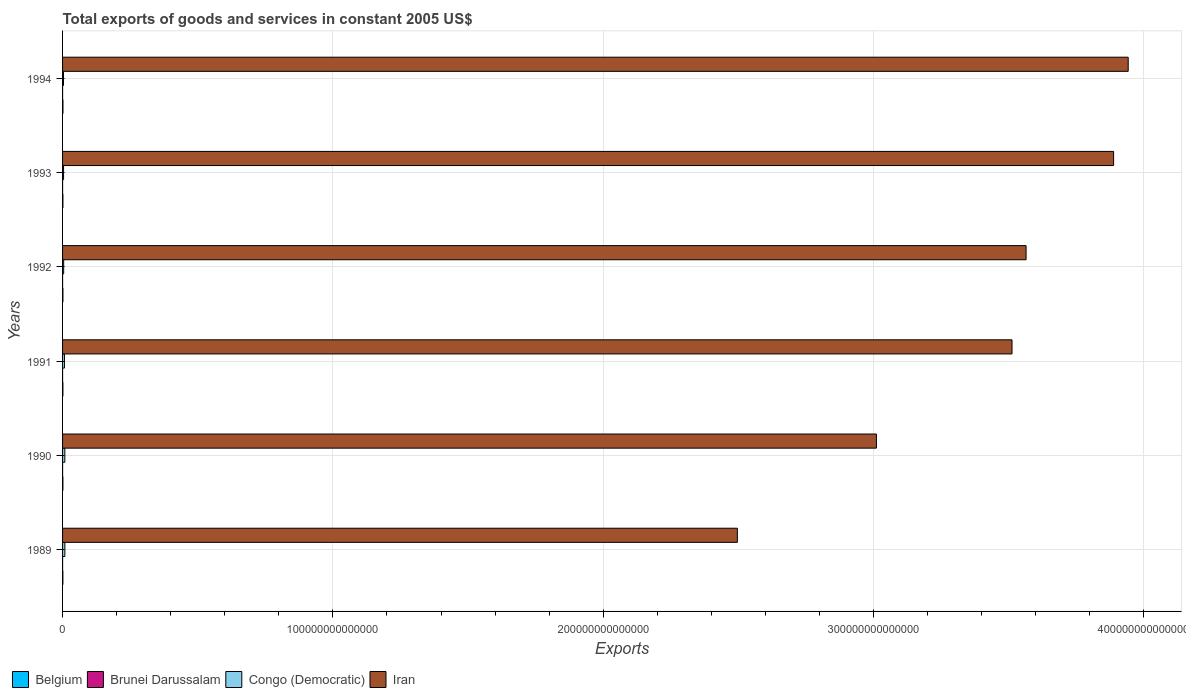Are the number of bars on each tick of the Y-axis equal?
Give a very brief answer. Yes. How many bars are there on the 5th tick from the bottom?
Make the answer very short. 4. What is the label of the 6th group of bars from the top?
Your answer should be compact. 1989. What is the total exports of goods and services in Congo (Democratic) in 1994?
Your answer should be very brief. 3.43e+11. Across all years, what is the maximum total exports of goods and services in Belgium?
Your answer should be very brief. 1.41e+11. Across all years, what is the minimum total exports of goods and services in Belgium?
Provide a succinct answer. 1.17e+11. In which year was the total exports of goods and services in Belgium maximum?
Offer a terse response. 1994. In which year was the total exports of goods and services in Brunei Darussalam minimum?
Give a very brief answer. 1989. What is the total total exports of goods and services in Congo (Democratic) in the graph?
Keep it short and to the point. 3.52e+12. What is the difference between the total exports of goods and services in Congo (Democratic) in 1989 and that in 1994?
Provide a succinct answer. 5.09e+11. What is the difference between the total exports of goods and services in Belgium in 1990 and the total exports of goods and services in Brunei Darussalam in 1993?
Offer a terse response. 1.17e+11. What is the average total exports of goods and services in Iran per year?
Provide a succinct answer. 3.40e+14. In the year 1989, what is the difference between the total exports of goods and services in Congo (Democratic) and total exports of goods and services in Iran?
Offer a very short reply. -2.49e+14. In how many years, is the total exports of goods and services in Iran greater than 140000000000000 US$?
Provide a short and direct response. 6. What is the ratio of the total exports of goods and services in Belgium in 1992 to that in 1993?
Ensure brevity in your answer.  1. Is the total exports of goods and services in Iran in 1992 less than that in 1994?
Offer a terse response. Yes. Is the difference between the total exports of goods and services in Congo (Democratic) in 1991 and 1992 greater than the difference between the total exports of goods and services in Iran in 1991 and 1992?
Offer a very short reply. Yes. What is the difference between the highest and the second highest total exports of goods and services in Belgium?
Offer a very short reply. 1.03e+1. What is the difference between the highest and the lowest total exports of goods and services in Brunei Darussalam?
Offer a very short reply. 8.16e+08. In how many years, is the total exports of goods and services in Iran greater than the average total exports of goods and services in Iran taken over all years?
Your answer should be compact. 4. Is it the case that in every year, the sum of the total exports of goods and services in Iran and total exports of goods and services in Belgium is greater than the sum of total exports of goods and services in Congo (Democratic) and total exports of goods and services in Brunei Darussalam?
Your answer should be compact. No. What does the 1st bar from the top in 1992 represents?
Make the answer very short. Iran. What does the 2nd bar from the bottom in 1991 represents?
Provide a succinct answer. Brunei Darussalam. How many bars are there?
Offer a terse response. 24. What is the difference between two consecutive major ticks on the X-axis?
Ensure brevity in your answer.  1.00e+14. Does the graph contain grids?
Your answer should be very brief. Yes. Where does the legend appear in the graph?
Make the answer very short. Bottom left. How many legend labels are there?
Make the answer very short. 4. What is the title of the graph?
Offer a very short reply. Total exports of goods and services in constant 2005 US$. Does "Lesotho" appear as one of the legend labels in the graph?
Keep it short and to the point. No. What is the label or title of the X-axis?
Make the answer very short. Exports. What is the Exports of Belgium in 1989?
Your answer should be very brief. 1.17e+11. What is the Exports in Brunei Darussalam in 1989?
Offer a terse response. 4.85e+09. What is the Exports of Congo (Democratic) in 1989?
Make the answer very short. 8.52e+11. What is the Exports of Iran in 1989?
Keep it short and to the point. 2.50e+14. What is the Exports of Belgium in 1990?
Your answer should be very brief. 1.22e+11. What is the Exports of Brunei Darussalam in 1990?
Make the answer very short. 4.92e+09. What is the Exports of Congo (Democratic) in 1990?
Give a very brief answer. 8.44e+11. What is the Exports of Iran in 1990?
Give a very brief answer. 3.01e+14. What is the Exports in Belgium in 1991?
Your response must be concise. 1.26e+11. What is the Exports of Brunei Darussalam in 1991?
Your answer should be compact. 5.35e+09. What is the Exports in Congo (Democratic) in 1991?
Offer a terse response. 7.00e+11. What is the Exports in Iran in 1991?
Your answer should be very brief. 3.51e+14. What is the Exports in Belgium in 1992?
Ensure brevity in your answer.  1.31e+11. What is the Exports in Brunei Darussalam in 1992?
Make the answer very short. 5.67e+09. What is the Exports of Congo (Democratic) in 1992?
Provide a short and direct response. 4.08e+11. What is the Exports of Iran in 1992?
Make the answer very short. 3.56e+14. What is the Exports of Belgium in 1993?
Your answer should be compact. 1.30e+11. What is the Exports in Brunei Darussalam in 1993?
Provide a succinct answer. 5.51e+09. What is the Exports in Congo (Democratic) in 1993?
Give a very brief answer. 3.71e+11. What is the Exports in Iran in 1993?
Offer a terse response. 3.89e+14. What is the Exports in Belgium in 1994?
Your answer should be compact. 1.41e+11. What is the Exports of Brunei Darussalam in 1994?
Keep it short and to the point. 5.67e+09. What is the Exports in Congo (Democratic) in 1994?
Your response must be concise. 3.43e+11. What is the Exports of Iran in 1994?
Make the answer very short. 3.94e+14. Across all years, what is the maximum Exports of Belgium?
Your answer should be very brief. 1.41e+11. Across all years, what is the maximum Exports of Brunei Darussalam?
Your response must be concise. 5.67e+09. Across all years, what is the maximum Exports in Congo (Democratic)?
Provide a short and direct response. 8.52e+11. Across all years, what is the maximum Exports of Iran?
Your answer should be compact. 3.94e+14. Across all years, what is the minimum Exports of Belgium?
Provide a succinct answer. 1.17e+11. Across all years, what is the minimum Exports in Brunei Darussalam?
Provide a short and direct response. 4.85e+09. Across all years, what is the minimum Exports of Congo (Democratic)?
Offer a terse response. 3.43e+11. Across all years, what is the minimum Exports in Iran?
Provide a succinct answer. 2.50e+14. What is the total Exports of Belgium in the graph?
Provide a short and direct response. 7.68e+11. What is the total Exports in Brunei Darussalam in the graph?
Keep it short and to the point. 3.20e+1. What is the total Exports of Congo (Democratic) in the graph?
Your answer should be compact. 3.52e+12. What is the total Exports in Iran in the graph?
Your answer should be compact. 2.04e+15. What is the difference between the Exports in Belgium in 1989 and that in 1990?
Provide a succinct answer. -5.35e+09. What is the difference between the Exports in Brunei Darussalam in 1989 and that in 1990?
Provide a short and direct response. -6.20e+07. What is the difference between the Exports in Congo (Democratic) in 1989 and that in 1990?
Give a very brief answer. 8.36e+09. What is the difference between the Exports of Iran in 1989 and that in 1990?
Offer a terse response. -5.14e+13. What is the difference between the Exports in Belgium in 1989 and that in 1991?
Offer a terse response. -9.09e+09. What is the difference between the Exports of Brunei Darussalam in 1989 and that in 1991?
Make the answer very short. -4.93e+08. What is the difference between the Exports of Congo (Democratic) in 1989 and that in 1991?
Provide a short and direct response. 1.53e+11. What is the difference between the Exports in Iran in 1989 and that in 1991?
Your answer should be very brief. -1.02e+14. What is the difference between the Exports of Belgium in 1989 and that in 1992?
Provide a short and direct response. -1.37e+1. What is the difference between the Exports in Brunei Darussalam in 1989 and that in 1992?
Your answer should be very brief. -8.16e+08. What is the difference between the Exports in Congo (Democratic) in 1989 and that in 1992?
Give a very brief answer. 4.45e+11. What is the difference between the Exports in Iran in 1989 and that in 1992?
Offer a terse response. -1.07e+14. What is the difference between the Exports in Belgium in 1989 and that in 1993?
Make the answer very short. -1.31e+1. What is the difference between the Exports of Brunei Darussalam in 1989 and that in 1993?
Ensure brevity in your answer.  -6.58e+08. What is the difference between the Exports in Congo (Democratic) in 1989 and that in 1993?
Make the answer very short. 4.81e+11. What is the difference between the Exports in Iran in 1989 and that in 1993?
Provide a short and direct response. -1.39e+14. What is the difference between the Exports in Belgium in 1989 and that in 1994?
Provide a short and direct response. -2.40e+1. What is the difference between the Exports of Brunei Darussalam in 1989 and that in 1994?
Ensure brevity in your answer.  -8.15e+08. What is the difference between the Exports of Congo (Democratic) in 1989 and that in 1994?
Offer a very short reply. 5.09e+11. What is the difference between the Exports of Iran in 1989 and that in 1994?
Your response must be concise. -1.45e+14. What is the difference between the Exports of Belgium in 1990 and that in 1991?
Give a very brief answer. -3.74e+09. What is the difference between the Exports of Brunei Darussalam in 1990 and that in 1991?
Offer a very short reply. -4.31e+08. What is the difference between the Exports of Congo (Democratic) in 1990 and that in 1991?
Offer a terse response. 1.44e+11. What is the difference between the Exports of Iran in 1990 and that in 1991?
Ensure brevity in your answer.  -5.02e+13. What is the difference between the Exports of Belgium in 1990 and that in 1992?
Keep it short and to the point. -8.37e+09. What is the difference between the Exports of Brunei Darussalam in 1990 and that in 1992?
Provide a short and direct response. -7.54e+08. What is the difference between the Exports of Congo (Democratic) in 1990 and that in 1992?
Your answer should be compact. 4.37e+11. What is the difference between the Exports in Iran in 1990 and that in 1992?
Your answer should be compact. -5.54e+13. What is the difference between the Exports in Belgium in 1990 and that in 1993?
Offer a terse response. -7.79e+09. What is the difference between the Exports in Brunei Darussalam in 1990 and that in 1993?
Offer a terse response. -5.96e+08. What is the difference between the Exports of Congo (Democratic) in 1990 and that in 1993?
Make the answer very short. 4.73e+11. What is the difference between the Exports of Iran in 1990 and that in 1993?
Offer a very short reply. -8.77e+13. What is the difference between the Exports in Belgium in 1990 and that in 1994?
Your answer should be very brief. -1.86e+1. What is the difference between the Exports of Brunei Darussalam in 1990 and that in 1994?
Offer a terse response. -7.53e+08. What is the difference between the Exports in Congo (Democratic) in 1990 and that in 1994?
Your answer should be compact. 5.01e+11. What is the difference between the Exports in Iran in 1990 and that in 1994?
Keep it short and to the point. -9.31e+13. What is the difference between the Exports of Belgium in 1991 and that in 1992?
Your answer should be compact. -4.63e+09. What is the difference between the Exports in Brunei Darussalam in 1991 and that in 1992?
Provide a succinct answer. -3.23e+08. What is the difference between the Exports in Congo (Democratic) in 1991 and that in 1992?
Offer a very short reply. 2.92e+11. What is the difference between the Exports in Iran in 1991 and that in 1992?
Your answer should be compact. -5.20e+12. What is the difference between the Exports in Belgium in 1991 and that in 1993?
Provide a succinct answer. -4.05e+09. What is the difference between the Exports of Brunei Darussalam in 1991 and that in 1993?
Ensure brevity in your answer.  -1.65e+08. What is the difference between the Exports of Congo (Democratic) in 1991 and that in 1993?
Ensure brevity in your answer.  3.28e+11. What is the difference between the Exports of Iran in 1991 and that in 1993?
Keep it short and to the point. -3.76e+13. What is the difference between the Exports of Belgium in 1991 and that in 1994?
Make the answer very short. -1.49e+1. What is the difference between the Exports of Brunei Darussalam in 1991 and that in 1994?
Give a very brief answer. -3.22e+08. What is the difference between the Exports in Congo (Democratic) in 1991 and that in 1994?
Provide a short and direct response. 3.56e+11. What is the difference between the Exports in Iran in 1991 and that in 1994?
Ensure brevity in your answer.  -4.30e+13. What is the difference between the Exports of Belgium in 1992 and that in 1993?
Make the answer very short. 5.78e+08. What is the difference between the Exports of Brunei Darussalam in 1992 and that in 1993?
Offer a very short reply. 1.58e+08. What is the difference between the Exports of Congo (Democratic) in 1992 and that in 1993?
Provide a succinct answer. 3.62e+1. What is the difference between the Exports of Iran in 1992 and that in 1993?
Your answer should be very brief. -3.24e+13. What is the difference between the Exports in Belgium in 1992 and that in 1994?
Your response must be concise. -1.03e+1. What is the difference between the Exports in Congo (Democratic) in 1992 and that in 1994?
Your response must be concise. 6.41e+1. What is the difference between the Exports of Iran in 1992 and that in 1994?
Your response must be concise. -3.78e+13. What is the difference between the Exports of Belgium in 1993 and that in 1994?
Your answer should be compact. -1.08e+1. What is the difference between the Exports in Brunei Darussalam in 1993 and that in 1994?
Give a very brief answer. -1.57e+08. What is the difference between the Exports of Congo (Democratic) in 1993 and that in 1994?
Give a very brief answer. 2.79e+1. What is the difference between the Exports in Iran in 1993 and that in 1994?
Your answer should be very brief. -5.40e+12. What is the difference between the Exports in Belgium in 1989 and the Exports in Brunei Darussalam in 1990?
Ensure brevity in your answer.  1.12e+11. What is the difference between the Exports in Belgium in 1989 and the Exports in Congo (Democratic) in 1990?
Offer a terse response. -7.27e+11. What is the difference between the Exports in Belgium in 1989 and the Exports in Iran in 1990?
Make the answer very short. -3.01e+14. What is the difference between the Exports of Brunei Darussalam in 1989 and the Exports of Congo (Democratic) in 1990?
Make the answer very short. -8.39e+11. What is the difference between the Exports of Brunei Darussalam in 1989 and the Exports of Iran in 1990?
Your response must be concise. -3.01e+14. What is the difference between the Exports in Congo (Democratic) in 1989 and the Exports in Iran in 1990?
Provide a succinct answer. -3.00e+14. What is the difference between the Exports of Belgium in 1989 and the Exports of Brunei Darussalam in 1991?
Give a very brief answer. 1.12e+11. What is the difference between the Exports of Belgium in 1989 and the Exports of Congo (Democratic) in 1991?
Give a very brief answer. -5.83e+11. What is the difference between the Exports of Belgium in 1989 and the Exports of Iran in 1991?
Your response must be concise. -3.51e+14. What is the difference between the Exports in Brunei Darussalam in 1989 and the Exports in Congo (Democratic) in 1991?
Ensure brevity in your answer.  -6.95e+11. What is the difference between the Exports in Brunei Darussalam in 1989 and the Exports in Iran in 1991?
Ensure brevity in your answer.  -3.51e+14. What is the difference between the Exports in Congo (Democratic) in 1989 and the Exports in Iran in 1991?
Offer a terse response. -3.50e+14. What is the difference between the Exports in Belgium in 1989 and the Exports in Brunei Darussalam in 1992?
Give a very brief answer. 1.11e+11. What is the difference between the Exports in Belgium in 1989 and the Exports in Congo (Democratic) in 1992?
Your answer should be compact. -2.90e+11. What is the difference between the Exports in Belgium in 1989 and the Exports in Iran in 1992?
Your response must be concise. -3.56e+14. What is the difference between the Exports in Brunei Darussalam in 1989 and the Exports in Congo (Democratic) in 1992?
Your answer should be compact. -4.03e+11. What is the difference between the Exports of Brunei Darussalam in 1989 and the Exports of Iran in 1992?
Make the answer very short. -3.56e+14. What is the difference between the Exports of Congo (Democratic) in 1989 and the Exports of Iran in 1992?
Provide a succinct answer. -3.56e+14. What is the difference between the Exports in Belgium in 1989 and the Exports in Brunei Darussalam in 1993?
Your answer should be compact. 1.12e+11. What is the difference between the Exports of Belgium in 1989 and the Exports of Congo (Democratic) in 1993?
Give a very brief answer. -2.54e+11. What is the difference between the Exports in Belgium in 1989 and the Exports in Iran in 1993?
Give a very brief answer. -3.89e+14. What is the difference between the Exports in Brunei Darussalam in 1989 and the Exports in Congo (Democratic) in 1993?
Your response must be concise. -3.66e+11. What is the difference between the Exports in Brunei Darussalam in 1989 and the Exports in Iran in 1993?
Offer a very short reply. -3.89e+14. What is the difference between the Exports of Congo (Democratic) in 1989 and the Exports of Iran in 1993?
Your response must be concise. -3.88e+14. What is the difference between the Exports in Belgium in 1989 and the Exports in Brunei Darussalam in 1994?
Your answer should be compact. 1.11e+11. What is the difference between the Exports of Belgium in 1989 and the Exports of Congo (Democratic) in 1994?
Make the answer very short. -2.26e+11. What is the difference between the Exports of Belgium in 1989 and the Exports of Iran in 1994?
Your answer should be very brief. -3.94e+14. What is the difference between the Exports in Brunei Darussalam in 1989 and the Exports in Congo (Democratic) in 1994?
Offer a terse response. -3.39e+11. What is the difference between the Exports of Brunei Darussalam in 1989 and the Exports of Iran in 1994?
Your answer should be compact. -3.94e+14. What is the difference between the Exports in Congo (Democratic) in 1989 and the Exports in Iran in 1994?
Your answer should be compact. -3.93e+14. What is the difference between the Exports in Belgium in 1990 and the Exports in Brunei Darussalam in 1991?
Keep it short and to the point. 1.17e+11. What is the difference between the Exports of Belgium in 1990 and the Exports of Congo (Democratic) in 1991?
Your answer should be compact. -5.77e+11. What is the difference between the Exports in Belgium in 1990 and the Exports in Iran in 1991?
Offer a very short reply. -3.51e+14. What is the difference between the Exports in Brunei Darussalam in 1990 and the Exports in Congo (Democratic) in 1991?
Offer a very short reply. -6.95e+11. What is the difference between the Exports in Brunei Darussalam in 1990 and the Exports in Iran in 1991?
Keep it short and to the point. -3.51e+14. What is the difference between the Exports of Congo (Democratic) in 1990 and the Exports of Iran in 1991?
Keep it short and to the point. -3.50e+14. What is the difference between the Exports of Belgium in 1990 and the Exports of Brunei Darussalam in 1992?
Make the answer very short. 1.17e+11. What is the difference between the Exports of Belgium in 1990 and the Exports of Congo (Democratic) in 1992?
Offer a terse response. -2.85e+11. What is the difference between the Exports in Belgium in 1990 and the Exports in Iran in 1992?
Your response must be concise. -3.56e+14. What is the difference between the Exports of Brunei Darussalam in 1990 and the Exports of Congo (Democratic) in 1992?
Provide a short and direct response. -4.03e+11. What is the difference between the Exports in Brunei Darussalam in 1990 and the Exports in Iran in 1992?
Give a very brief answer. -3.56e+14. What is the difference between the Exports of Congo (Democratic) in 1990 and the Exports of Iran in 1992?
Ensure brevity in your answer.  -3.56e+14. What is the difference between the Exports of Belgium in 1990 and the Exports of Brunei Darussalam in 1993?
Your response must be concise. 1.17e+11. What is the difference between the Exports in Belgium in 1990 and the Exports in Congo (Democratic) in 1993?
Ensure brevity in your answer.  -2.49e+11. What is the difference between the Exports of Belgium in 1990 and the Exports of Iran in 1993?
Your response must be concise. -3.89e+14. What is the difference between the Exports of Brunei Darussalam in 1990 and the Exports of Congo (Democratic) in 1993?
Your response must be concise. -3.66e+11. What is the difference between the Exports of Brunei Darussalam in 1990 and the Exports of Iran in 1993?
Provide a short and direct response. -3.89e+14. What is the difference between the Exports in Congo (Democratic) in 1990 and the Exports in Iran in 1993?
Your answer should be compact. -3.88e+14. What is the difference between the Exports in Belgium in 1990 and the Exports in Brunei Darussalam in 1994?
Your answer should be compact. 1.17e+11. What is the difference between the Exports of Belgium in 1990 and the Exports of Congo (Democratic) in 1994?
Provide a succinct answer. -2.21e+11. What is the difference between the Exports in Belgium in 1990 and the Exports in Iran in 1994?
Give a very brief answer. -3.94e+14. What is the difference between the Exports in Brunei Darussalam in 1990 and the Exports in Congo (Democratic) in 1994?
Your answer should be compact. -3.39e+11. What is the difference between the Exports of Brunei Darussalam in 1990 and the Exports of Iran in 1994?
Provide a short and direct response. -3.94e+14. What is the difference between the Exports in Congo (Democratic) in 1990 and the Exports in Iran in 1994?
Offer a very short reply. -3.93e+14. What is the difference between the Exports of Belgium in 1991 and the Exports of Brunei Darussalam in 1992?
Give a very brief answer. 1.20e+11. What is the difference between the Exports in Belgium in 1991 and the Exports in Congo (Democratic) in 1992?
Your answer should be very brief. -2.81e+11. What is the difference between the Exports of Belgium in 1991 and the Exports of Iran in 1992?
Offer a terse response. -3.56e+14. What is the difference between the Exports of Brunei Darussalam in 1991 and the Exports of Congo (Democratic) in 1992?
Make the answer very short. -4.02e+11. What is the difference between the Exports in Brunei Darussalam in 1991 and the Exports in Iran in 1992?
Offer a terse response. -3.56e+14. What is the difference between the Exports in Congo (Democratic) in 1991 and the Exports in Iran in 1992?
Your response must be concise. -3.56e+14. What is the difference between the Exports of Belgium in 1991 and the Exports of Brunei Darussalam in 1993?
Provide a succinct answer. 1.21e+11. What is the difference between the Exports in Belgium in 1991 and the Exports in Congo (Democratic) in 1993?
Keep it short and to the point. -2.45e+11. What is the difference between the Exports of Belgium in 1991 and the Exports of Iran in 1993?
Give a very brief answer. -3.89e+14. What is the difference between the Exports of Brunei Darussalam in 1991 and the Exports of Congo (Democratic) in 1993?
Provide a short and direct response. -3.66e+11. What is the difference between the Exports in Brunei Darussalam in 1991 and the Exports in Iran in 1993?
Ensure brevity in your answer.  -3.89e+14. What is the difference between the Exports of Congo (Democratic) in 1991 and the Exports of Iran in 1993?
Your answer should be very brief. -3.88e+14. What is the difference between the Exports of Belgium in 1991 and the Exports of Brunei Darussalam in 1994?
Your response must be concise. 1.20e+11. What is the difference between the Exports of Belgium in 1991 and the Exports of Congo (Democratic) in 1994?
Provide a short and direct response. -2.17e+11. What is the difference between the Exports of Belgium in 1991 and the Exports of Iran in 1994?
Keep it short and to the point. -3.94e+14. What is the difference between the Exports of Brunei Darussalam in 1991 and the Exports of Congo (Democratic) in 1994?
Ensure brevity in your answer.  -3.38e+11. What is the difference between the Exports of Brunei Darussalam in 1991 and the Exports of Iran in 1994?
Your answer should be compact. -3.94e+14. What is the difference between the Exports of Congo (Democratic) in 1991 and the Exports of Iran in 1994?
Make the answer very short. -3.93e+14. What is the difference between the Exports of Belgium in 1992 and the Exports of Brunei Darussalam in 1993?
Offer a very short reply. 1.25e+11. What is the difference between the Exports of Belgium in 1992 and the Exports of Congo (Democratic) in 1993?
Give a very brief answer. -2.41e+11. What is the difference between the Exports in Belgium in 1992 and the Exports in Iran in 1993?
Make the answer very short. -3.89e+14. What is the difference between the Exports in Brunei Darussalam in 1992 and the Exports in Congo (Democratic) in 1993?
Your answer should be very brief. -3.66e+11. What is the difference between the Exports of Brunei Darussalam in 1992 and the Exports of Iran in 1993?
Your answer should be very brief. -3.89e+14. What is the difference between the Exports in Congo (Democratic) in 1992 and the Exports in Iran in 1993?
Offer a very short reply. -3.88e+14. What is the difference between the Exports of Belgium in 1992 and the Exports of Brunei Darussalam in 1994?
Provide a succinct answer. 1.25e+11. What is the difference between the Exports in Belgium in 1992 and the Exports in Congo (Democratic) in 1994?
Offer a terse response. -2.13e+11. What is the difference between the Exports in Belgium in 1992 and the Exports in Iran in 1994?
Your answer should be compact. -3.94e+14. What is the difference between the Exports in Brunei Darussalam in 1992 and the Exports in Congo (Democratic) in 1994?
Provide a succinct answer. -3.38e+11. What is the difference between the Exports in Brunei Darussalam in 1992 and the Exports in Iran in 1994?
Ensure brevity in your answer.  -3.94e+14. What is the difference between the Exports of Congo (Democratic) in 1992 and the Exports of Iran in 1994?
Your answer should be very brief. -3.94e+14. What is the difference between the Exports of Belgium in 1993 and the Exports of Brunei Darussalam in 1994?
Make the answer very short. 1.25e+11. What is the difference between the Exports in Belgium in 1993 and the Exports in Congo (Democratic) in 1994?
Offer a very short reply. -2.13e+11. What is the difference between the Exports of Belgium in 1993 and the Exports of Iran in 1994?
Ensure brevity in your answer.  -3.94e+14. What is the difference between the Exports in Brunei Darussalam in 1993 and the Exports in Congo (Democratic) in 1994?
Make the answer very short. -3.38e+11. What is the difference between the Exports of Brunei Darussalam in 1993 and the Exports of Iran in 1994?
Your response must be concise. -3.94e+14. What is the difference between the Exports in Congo (Democratic) in 1993 and the Exports in Iran in 1994?
Ensure brevity in your answer.  -3.94e+14. What is the average Exports in Belgium per year?
Make the answer very short. 1.28e+11. What is the average Exports of Brunei Darussalam per year?
Offer a terse response. 5.33e+09. What is the average Exports in Congo (Democratic) per year?
Keep it short and to the point. 5.86e+11. What is the average Exports of Iran per year?
Provide a succinct answer. 3.40e+14. In the year 1989, what is the difference between the Exports of Belgium and Exports of Brunei Darussalam?
Your response must be concise. 1.12e+11. In the year 1989, what is the difference between the Exports of Belgium and Exports of Congo (Democratic)?
Your response must be concise. -7.35e+11. In the year 1989, what is the difference between the Exports in Belgium and Exports in Iran?
Your answer should be compact. -2.49e+14. In the year 1989, what is the difference between the Exports in Brunei Darussalam and Exports in Congo (Democratic)?
Ensure brevity in your answer.  -8.48e+11. In the year 1989, what is the difference between the Exports in Brunei Darussalam and Exports in Iran?
Keep it short and to the point. -2.50e+14. In the year 1989, what is the difference between the Exports in Congo (Democratic) and Exports in Iran?
Provide a succinct answer. -2.49e+14. In the year 1990, what is the difference between the Exports in Belgium and Exports in Brunei Darussalam?
Offer a very short reply. 1.17e+11. In the year 1990, what is the difference between the Exports in Belgium and Exports in Congo (Democratic)?
Provide a short and direct response. -7.22e+11. In the year 1990, what is the difference between the Exports in Belgium and Exports in Iran?
Offer a very short reply. -3.01e+14. In the year 1990, what is the difference between the Exports of Brunei Darussalam and Exports of Congo (Democratic)?
Your response must be concise. -8.39e+11. In the year 1990, what is the difference between the Exports in Brunei Darussalam and Exports in Iran?
Make the answer very short. -3.01e+14. In the year 1990, what is the difference between the Exports in Congo (Democratic) and Exports in Iran?
Offer a very short reply. -3.00e+14. In the year 1991, what is the difference between the Exports of Belgium and Exports of Brunei Darussalam?
Your answer should be compact. 1.21e+11. In the year 1991, what is the difference between the Exports of Belgium and Exports of Congo (Democratic)?
Make the answer very short. -5.73e+11. In the year 1991, what is the difference between the Exports in Belgium and Exports in Iran?
Provide a succinct answer. -3.51e+14. In the year 1991, what is the difference between the Exports of Brunei Darussalam and Exports of Congo (Democratic)?
Offer a very short reply. -6.94e+11. In the year 1991, what is the difference between the Exports in Brunei Darussalam and Exports in Iran?
Provide a succinct answer. -3.51e+14. In the year 1991, what is the difference between the Exports of Congo (Democratic) and Exports of Iran?
Keep it short and to the point. -3.51e+14. In the year 1992, what is the difference between the Exports of Belgium and Exports of Brunei Darussalam?
Offer a terse response. 1.25e+11. In the year 1992, what is the difference between the Exports in Belgium and Exports in Congo (Democratic)?
Your answer should be very brief. -2.77e+11. In the year 1992, what is the difference between the Exports of Belgium and Exports of Iran?
Provide a succinct answer. -3.56e+14. In the year 1992, what is the difference between the Exports of Brunei Darussalam and Exports of Congo (Democratic)?
Give a very brief answer. -4.02e+11. In the year 1992, what is the difference between the Exports in Brunei Darussalam and Exports in Iran?
Offer a very short reply. -3.56e+14. In the year 1992, what is the difference between the Exports in Congo (Democratic) and Exports in Iran?
Offer a terse response. -3.56e+14. In the year 1993, what is the difference between the Exports in Belgium and Exports in Brunei Darussalam?
Offer a very short reply. 1.25e+11. In the year 1993, what is the difference between the Exports in Belgium and Exports in Congo (Democratic)?
Your answer should be compact. -2.41e+11. In the year 1993, what is the difference between the Exports in Belgium and Exports in Iran?
Your response must be concise. -3.89e+14. In the year 1993, what is the difference between the Exports of Brunei Darussalam and Exports of Congo (Democratic)?
Give a very brief answer. -3.66e+11. In the year 1993, what is the difference between the Exports in Brunei Darussalam and Exports in Iran?
Offer a terse response. -3.89e+14. In the year 1993, what is the difference between the Exports of Congo (Democratic) and Exports of Iran?
Make the answer very short. -3.88e+14. In the year 1994, what is the difference between the Exports in Belgium and Exports in Brunei Darussalam?
Offer a very short reply. 1.35e+11. In the year 1994, what is the difference between the Exports in Belgium and Exports in Congo (Democratic)?
Provide a short and direct response. -2.02e+11. In the year 1994, what is the difference between the Exports in Belgium and Exports in Iran?
Make the answer very short. -3.94e+14. In the year 1994, what is the difference between the Exports of Brunei Darussalam and Exports of Congo (Democratic)?
Your response must be concise. -3.38e+11. In the year 1994, what is the difference between the Exports in Brunei Darussalam and Exports in Iran?
Offer a terse response. -3.94e+14. In the year 1994, what is the difference between the Exports of Congo (Democratic) and Exports of Iran?
Ensure brevity in your answer.  -3.94e+14. What is the ratio of the Exports of Belgium in 1989 to that in 1990?
Your response must be concise. 0.96. What is the ratio of the Exports in Brunei Darussalam in 1989 to that in 1990?
Your response must be concise. 0.99. What is the ratio of the Exports in Congo (Democratic) in 1989 to that in 1990?
Provide a succinct answer. 1.01. What is the ratio of the Exports in Iran in 1989 to that in 1990?
Your response must be concise. 0.83. What is the ratio of the Exports of Belgium in 1989 to that in 1991?
Your answer should be compact. 0.93. What is the ratio of the Exports of Brunei Darussalam in 1989 to that in 1991?
Your response must be concise. 0.91. What is the ratio of the Exports in Congo (Democratic) in 1989 to that in 1991?
Make the answer very short. 1.22. What is the ratio of the Exports of Iran in 1989 to that in 1991?
Offer a very short reply. 0.71. What is the ratio of the Exports of Belgium in 1989 to that in 1992?
Your answer should be compact. 0.9. What is the ratio of the Exports in Brunei Darussalam in 1989 to that in 1992?
Provide a short and direct response. 0.86. What is the ratio of the Exports of Congo (Democratic) in 1989 to that in 1992?
Keep it short and to the point. 2.09. What is the ratio of the Exports of Iran in 1989 to that in 1992?
Offer a terse response. 0.7. What is the ratio of the Exports in Belgium in 1989 to that in 1993?
Ensure brevity in your answer.  0.9. What is the ratio of the Exports of Brunei Darussalam in 1989 to that in 1993?
Your answer should be very brief. 0.88. What is the ratio of the Exports in Congo (Democratic) in 1989 to that in 1993?
Your answer should be compact. 2.3. What is the ratio of the Exports of Iran in 1989 to that in 1993?
Ensure brevity in your answer.  0.64. What is the ratio of the Exports of Belgium in 1989 to that in 1994?
Offer a terse response. 0.83. What is the ratio of the Exports in Brunei Darussalam in 1989 to that in 1994?
Provide a short and direct response. 0.86. What is the ratio of the Exports of Congo (Democratic) in 1989 to that in 1994?
Give a very brief answer. 2.48. What is the ratio of the Exports of Iran in 1989 to that in 1994?
Your response must be concise. 0.63. What is the ratio of the Exports of Belgium in 1990 to that in 1991?
Make the answer very short. 0.97. What is the ratio of the Exports of Brunei Darussalam in 1990 to that in 1991?
Your answer should be very brief. 0.92. What is the ratio of the Exports in Congo (Democratic) in 1990 to that in 1991?
Provide a succinct answer. 1.21. What is the ratio of the Exports of Iran in 1990 to that in 1991?
Keep it short and to the point. 0.86. What is the ratio of the Exports of Belgium in 1990 to that in 1992?
Ensure brevity in your answer.  0.94. What is the ratio of the Exports in Brunei Darussalam in 1990 to that in 1992?
Provide a succinct answer. 0.87. What is the ratio of the Exports of Congo (Democratic) in 1990 to that in 1992?
Ensure brevity in your answer.  2.07. What is the ratio of the Exports of Iran in 1990 to that in 1992?
Your answer should be compact. 0.84. What is the ratio of the Exports of Belgium in 1990 to that in 1993?
Your answer should be very brief. 0.94. What is the ratio of the Exports of Brunei Darussalam in 1990 to that in 1993?
Offer a terse response. 0.89. What is the ratio of the Exports of Congo (Democratic) in 1990 to that in 1993?
Provide a succinct answer. 2.27. What is the ratio of the Exports in Iran in 1990 to that in 1993?
Make the answer very short. 0.77. What is the ratio of the Exports of Belgium in 1990 to that in 1994?
Ensure brevity in your answer.  0.87. What is the ratio of the Exports of Brunei Darussalam in 1990 to that in 1994?
Your response must be concise. 0.87. What is the ratio of the Exports in Congo (Democratic) in 1990 to that in 1994?
Provide a short and direct response. 2.46. What is the ratio of the Exports in Iran in 1990 to that in 1994?
Make the answer very short. 0.76. What is the ratio of the Exports of Belgium in 1991 to that in 1992?
Keep it short and to the point. 0.96. What is the ratio of the Exports in Brunei Darussalam in 1991 to that in 1992?
Make the answer very short. 0.94. What is the ratio of the Exports of Congo (Democratic) in 1991 to that in 1992?
Offer a terse response. 1.72. What is the ratio of the Exports of Iran in 1991 to that in 1992?
Keep it short and to the point. 0.99. What is the ratio of the Exports of Belgium in 1991 to that in 1993?
Your response must be concise. 0.97. What is the ratio of the Exports in Brunei Darussalam in 1991 to that in 1993?
Your answer should be compact. 0.97. What is the ratio of the Exports of Congo (Democratic) in 1991 to that in 1993?
Ensure brevity in your answer.  1.88. What is the ratio of the Exports of Iran in 1991 to that in 1993?
Keep it short and to the point. 0.9. What is the ratio of the Exports in Belgium in 1991 to that in 1994?
Make the answer very short. 0.89. What is the ratio of the Exports in Brunei Darussalam in 1991 to that in 1994?
Your answer should be compact. 0.94. What is the ratio of the Exports in Congo (Democratic) in 1991 to that in 1994?
Ensure brevity in your answer.  2.04. What is the ratio of the Exports of Iran in 1991 to that in 1994?
Offer a very short reply. 0.89. What is the ratio of the Exports in Belgium in 1992 to that in 1993?
Provide a succinct answer. 1. What is the ratio of the Exports in Brunei Darussalam in 1992 to that in 1993?
Provide a succinct answer. 1.03. What is the ratio of the Exports in Congo (Democratic) in 1992 to that in 1993?
Make the answer very short. 1.1. What is the ratio of the Exports of Belgium in 1992 to that in 1994?
Offer a terse response. 0.93. What is the ratio of the Exports of Brunei Darussalam in 1992 to that in 1994?
Provide a succinct answer. 1. What is the ratio of the Exports in Congo (Democratic) in 1992 to that in 1994?
Offer a terse response. 1.19. What is the ratio of the Exports in Iran in 1992 to that in 1994?
Ensure brevity in your answer.  0.9. What is the ratio of the Exports in Brunei Darussalam in 1993 to that in 1994?
Make the answer very short. 0.97. What is the ratio of the Exports of Congo (Democratic) in 1993 to that in 1994?
Provide a succinct answer. 1.08. What is the ratio of the Exports in Iran in 1993 to that in 1994?
Offer a very short reply. 0.99. What is the difference between the highest and the second highest Exports in Belgium?
Make the answer very short. 1.03e+1. What is the difference between the highest and the second highest Exports of Brunei Darussalam?
Your answer should be compact. 1.00e+06. What is the difference between the highest and the second highest Exports of Congo (Democratic)?
Provide a short and direct response. 8.36e+09. What is the difference between the highest and the second highest Exports in Iran?
Make the answer very short. 5.40e+12. What is the difference between the highest and the lowest Exports in Belgium?
Give a very brief answer. 2.40e+1. What is the difference between the highest and the lowest Exports in Brunei Darussalam?
Provide a short and direct response. 8.16e+08. What is the difference between the highest and the lowest Exports of Congo (Democratic)?
Keep it short and to the point. 5.09e+11. What is the difference between the highest and the lowest Exports in Iran?
Offer a very short reply. 1.45e+14. 